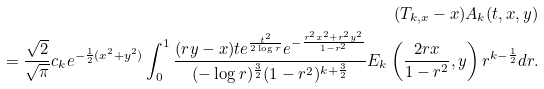Convert formula to latex. <formula><loc_0><loc_0><loc_500><loc_500>( T _ { k , x } - x ) A _ { k } ( t , x , y ) \\ = \frac { \sqrt { 2 } } { \sqrt { \pi } } c _ { k } e ^ { - \frac { 1 } { 2 } ( x ^ { 2 } + y ^ { 2 } ) } \int _ { 0 } ^ { 1 } \frac { ( r y - x ) t e ^ { \frac { t ^ { 2 } } { 2 \log r } } e ^ { - \frac { r ^ { 2 } x ^ { 2 } + r ^ { 2 } y ^ { 2 } } { 1 - r ^ { 2 } } } } { ( - \log r ) ^ { \frac { 3 } { 2 } } ( 1 - r ^ { 2 } ) ^ { k + \frac { 3 } { 2 } } } E _ { k } \left ( \frac { 2 r x } { 1 - r ^ { 2 } } , y \right ) r ^ { k - \frac { 1 } { 2 } } d r .</formula> 